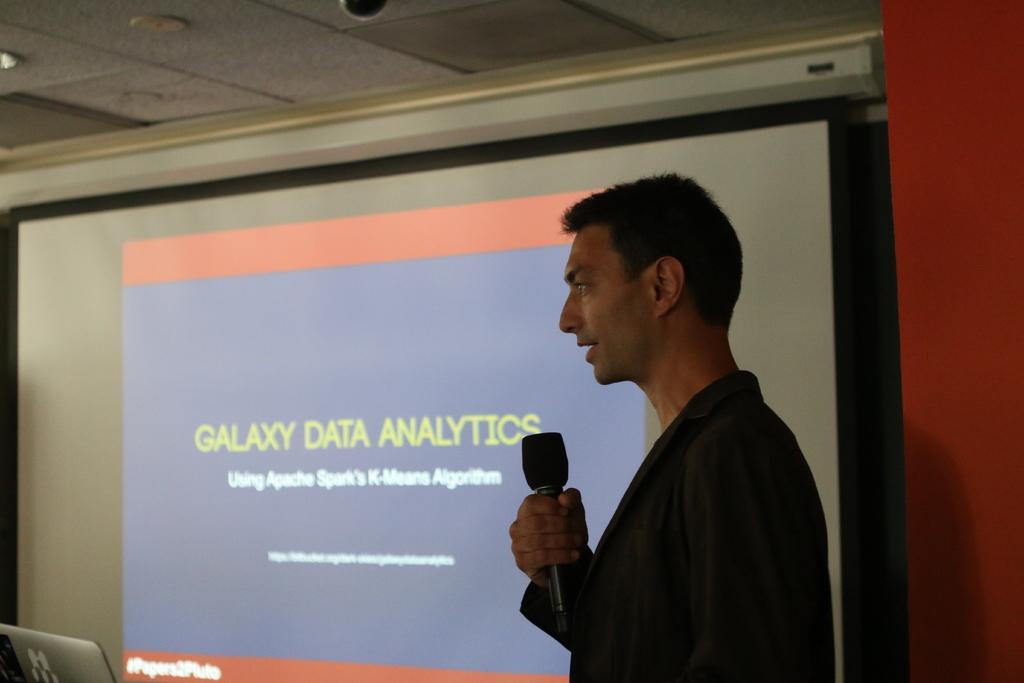How would you summarize this image in a sentence or two? As we can see in the image there is a screen, wall, laptop, a person wearing black color dress and holding a mic. 